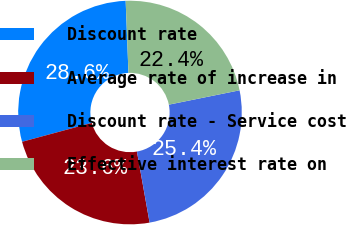Convert chart to OTSL. <chart><loc_0><loc_0><loc_500><loc_500><pie_chart><fcel>Discount rate<fcel>Average rate of increase in<fcel>Discount rate - Service cost<fcel>Effective interest rate on<nl><fcel>28.6%<fcel>23.59%<fcel>25.38%<fcel>22.43%<nl></chart> 